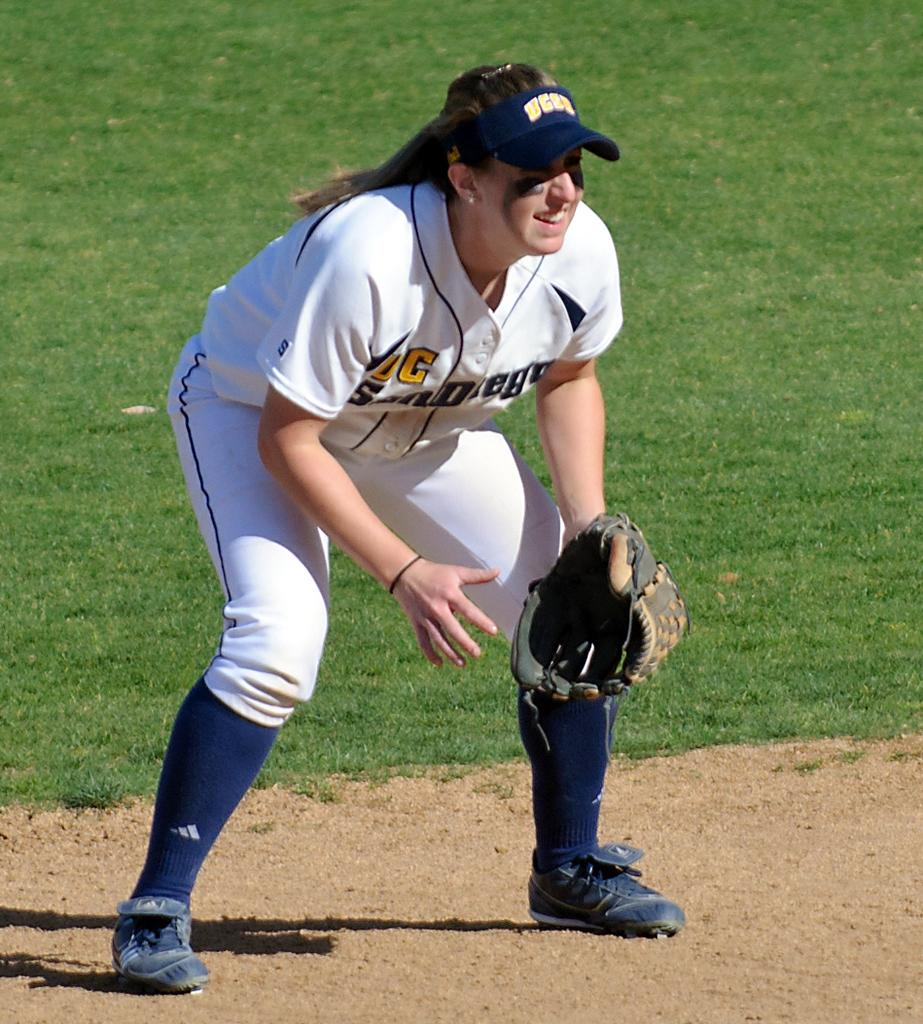Provide a one-sentence caption for the provided image. A female baseball player that has a visible G on her uniform. 